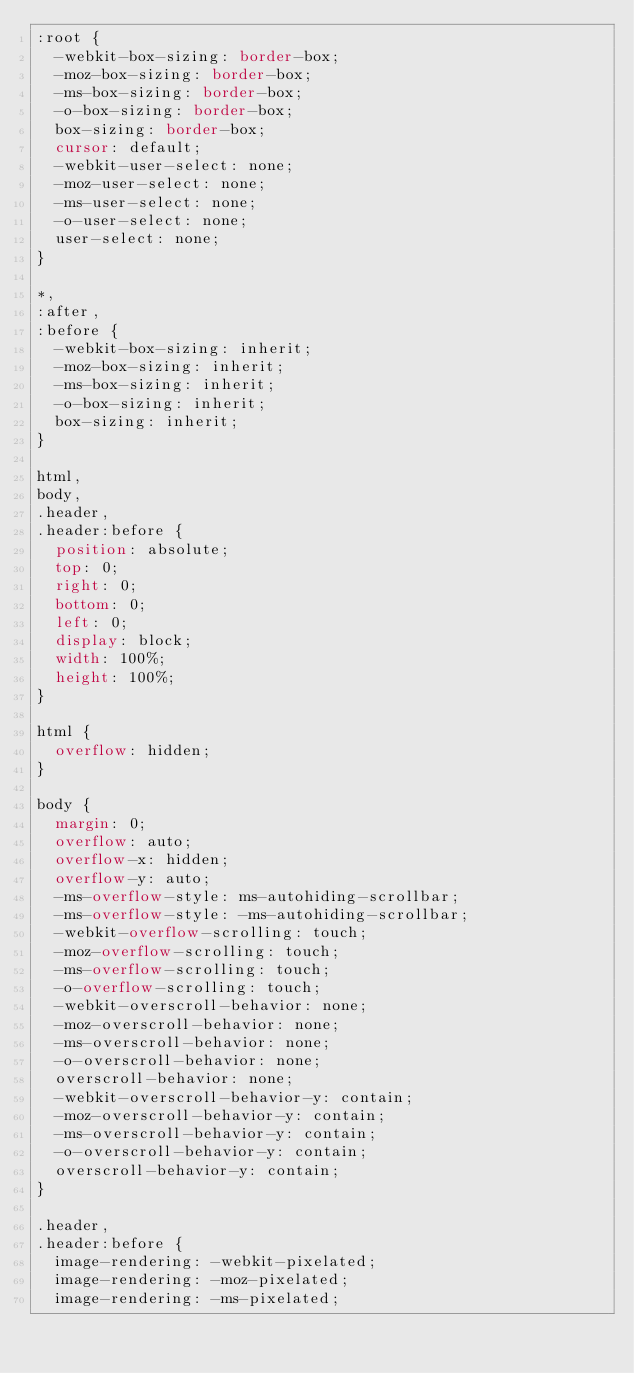<code> <loc_0><loc_0><loc_500><loc_500><_CSS_>:root {
  -webkit-box-sizing: border-box;
  -moz-box-sizing: border-box;
  -ms-box-sizing: border-box;
  -o-box-sizing: border-box;
  box-sizing: border-box;
  cursor: default;
  -webkit-user-select: none;
  -moz-user-select: none;
  -ms-user-select: none;
  -o-user-select: none;
  user-select: none;
}

*,
:after,
:before {
  -webkit-box-sizing: inherit;
  -moz-box-sizing: inherit;
  -ms-box-sizing: inherit;
  -o-box-sizing: inherit;
  box-sizing: inherit;
}

html,
body,
.header,
.header:before {
  position: absolute;
  top: 0;
  right: 0;
  bottom: 0;
  left: 0;
  display: block;
  width: 100%;
  height: 100%;
}

html {
  overflow: hidden;
}

body {
  margin: 0;
  overflow: auto;
  overflow-x: hidden;
  overflow-y: auto;
  -ms-overflow-style: ms-autohiding-scrollbar;
  -ms-overflow-style: -ms-autohiding-scrollbar;
  -webkit-overflow-scrolling: touch;
  -moz-overflow-scrolling: touch;
  -ms-overflow-scrolling: touch;
  -o-overflow-scrolling: touch;
  -webkit-overscroll-behavior: none;
  -moz-overscroll-behavior: none;
  -ms-overscroll-behavior: none;
  -o-overscroll-behavior: none;
  overscroll-behavior: none;
  -webkit-overscroll-behavior-y: contain;
  -moz-overscroll-behavior-y: contain;
  -ms-overscroll-behavior-y: contain;
  -o-overscroll-behavior-y: contain;
  overscroll-behavior-y: contain;
}

.header,
.header:before {
  image-rendering: -webkit-pixelated;
  image-rendering: -moz-pixelated;
  image-rendering: -ms-pixelated;</code> 